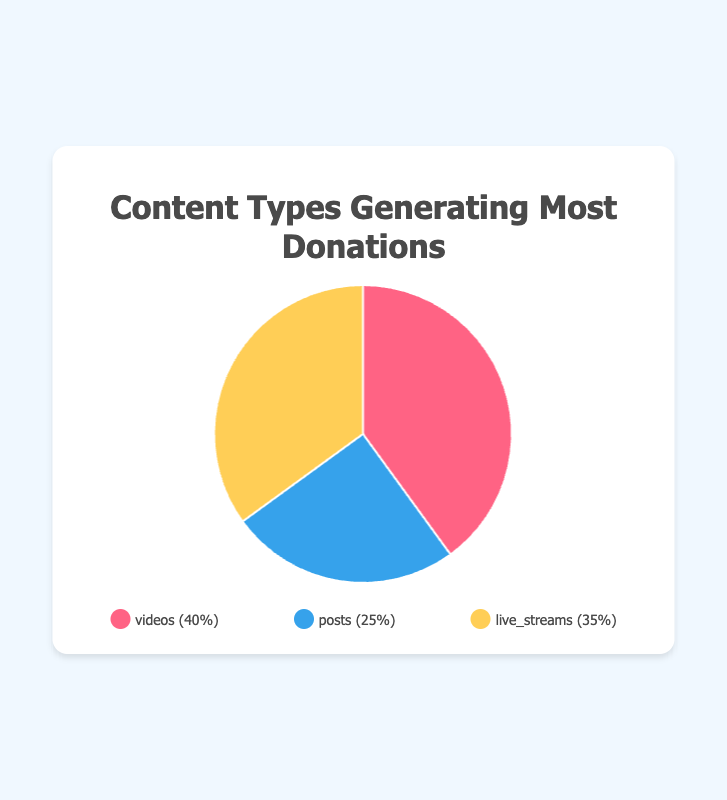Which type of content generated the most donations? To find the content type with the highest percentage of donations, look for the largest slice of the pie chart. The slice labeled 'videos' is the largest at 40%.
Answer: videos How much higher are the donations from videos compared to posts? The donations from videos are 40% and from posts are 25%. The difference can be calculated by subtracting 25 from 40. 40% - 25% = 15%.
Answer: 15% What is the combined percentage of donations from posts and live streams? Add the donation percentages for posts and live streams. Posts have 25% and live streams have 35%. 25% + 35% = 60%.
Answer: 60% What is the difference in donation percentage between live streams and videos? Subtract the percentage of live streams from videos. Videos have 40%, and live streams have 35%. 40% - 35% = 5%.
Answer: 5% Which content type has the smallest donation percentage? Look for the smallest slice of the pie chart. The slice labeled 'posts' is the smallest with 25%.
Answer: posts By how much do live streams exceed posts in generating donations? Subtract the percentage of posts from live streams. Live streams have 35%, and posts have 25%. 35% - 25% = 10%.
Answer: 10% What is the average percentage of donations across all content types? Sum the donation percentages of all content types and divide by the number of types. (40% + 25% + 35%) / 3 = 100% / 3 ≈ 33.33%.
Answer: 33.33% Which slice is represented by the color coded as red? Typically, the legend in the chart will indicate which color represents which slice. In this case, videos are represented by the color red.
Answer: videos Are donations from live streams greater than those from posts? Compare the donation percentages of live streams and posts. Live streams have 35%, while posts have 25%. 35% is greater than 25%.
Answer: Yes What is the ratio of donations from videos to the total percentage of donations from posts and live streams combined? The percentage for videos is 40%. The total percentage for posts and live streams combined is 60%. The ratio is calculated as 40% divided by 60%, which simplifies to 2/3 or approximately 0.67.
Answer: 0.67 